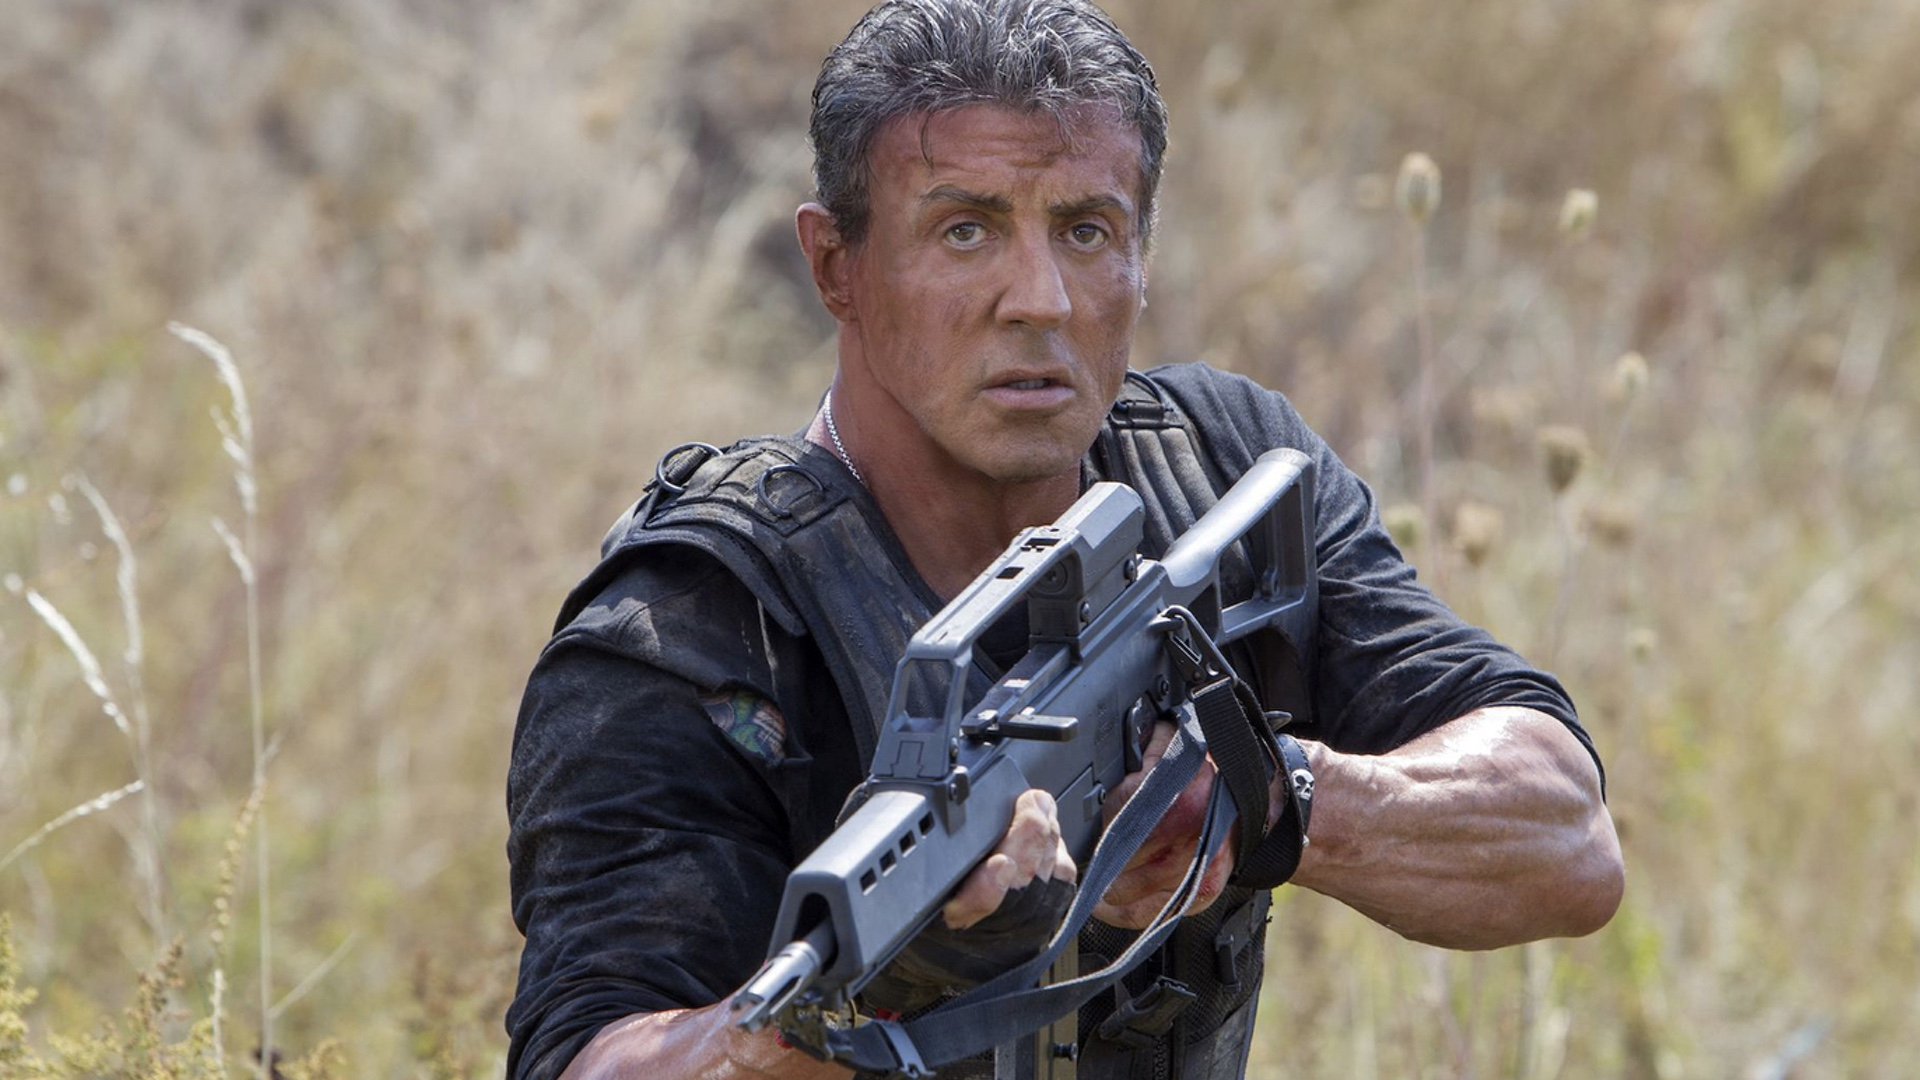If this were a scene from a movie, what would the soundtrack be like? The soundtrack for this scene would likely be filled with suspenseful and tense music, using sharp strings and rhythmic percussion to build an atmosphere of imminent danger. There might be a gradual crescendo leading up to a critical moment, heightening the viewer's sense of anticipation and anxiety. Imagine this scene as part of an epic tale, give a detailed narrative of the events leading to this moment. In the midst of a relentless battle for survival, our hero, a seasoned warrior known for his unmatched skills and resilience, has been tracking an elusive enemy through the dense wilderness. Days have turned into weeks as he navigates through treacherous terrain, relying on his instincts and training to survive. The stakes are high, as failing this mission could endanger countless lives. Finally, he arrives at this field, an unassuming location that hides the enemy’s hidden base. As he steadies himself, gripping his weapon tightly, the calm of the surroundings belies the imminent chaos. Every rustle in the tall grass could signal an ambush, every shadow a potential foe. The hero's heart races, but his mind remains laser-focused, ready to strike with precision. This moment is the culmination of a journey marked by sacrifice, pain, and an unwavering commitment to his cause. He knows that what happens next will define his legacy and the fate of his mission. The air is thick with tension as he prepares for the confrontation that could change everything. Create a very creative question related to this image. If this image were a snapshot taken by a time-traveling photographer documenting the most pivotal moments in an interdimensional war, what kind of advanced technology might the character be wielding, and how would it differ from current weaponry? 